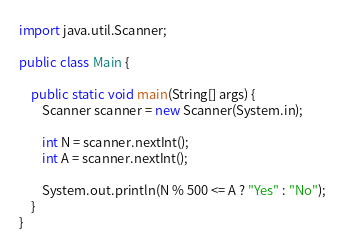<code> <loc_0><loc_0><loc_500><loc_500><_Java_>import java.util.Scanner;

public class Main {

    public static void main(String[] args) {
        Scanner scanner = new Scanner(System.in);

        int N = scanner.nextInt();
        int A = scanner.nextInt();

        System.out.println(N % 500 <= A ? "Yes" : "No");
    }
}
</code> 